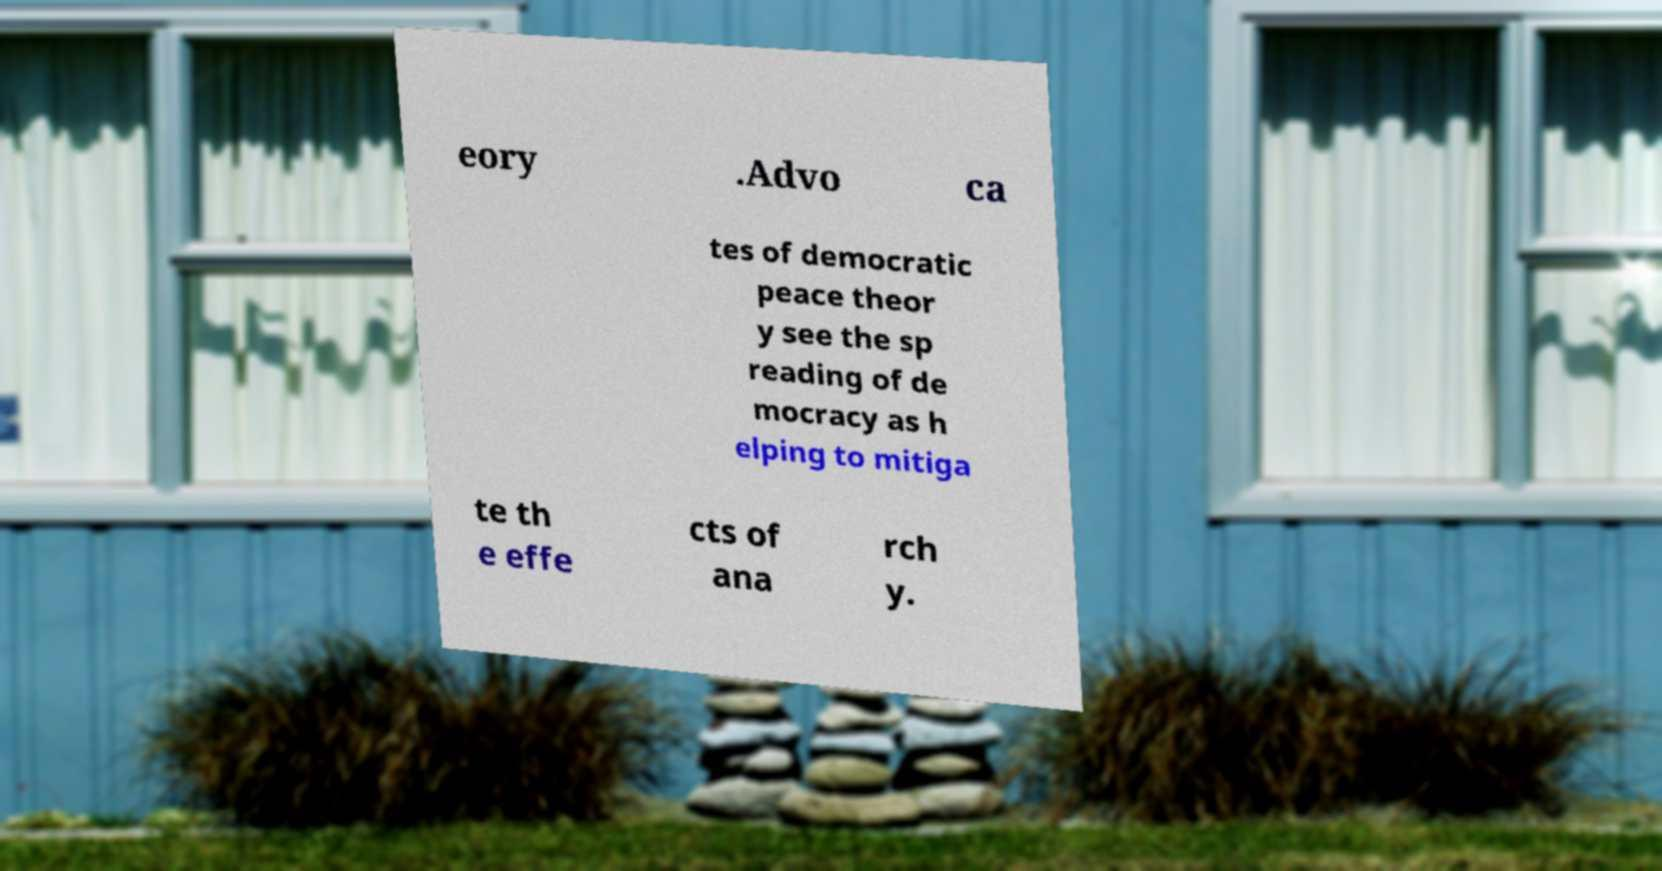I need the written content from this picture converted into text. Can you do that? eory .Advo ca tes of democratic peace theor y see the sp reading of de mocracy as h elping to mitiga te th e effe cts of ana rch y. 